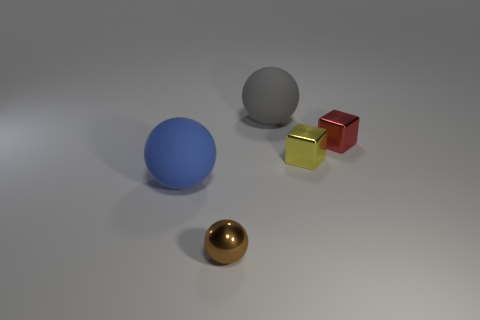What number of objects are either big rubber balls on the right side of the big blue sphere or metallic blocks?
Offer a very short reply. 3. Is the number of blue rubber objects in front of the tiny brown metal object greater than the number of matte spheres in front of the large blue thing?
Your answer should be compact. No. How many matte things are tiny balls or big balls?
Offer a terse response. 2. Is the number of tiny brown metallic objects left of the large gray object less than the number of big balls that are to the left of the brown sphere?
Offer a very short reply. No. How many objects are either tiny red shiny blocks or small objects that are to the left of the small red cube?
Offer a very short reply. 3. There is another object that is the same size as the blue object; what is it made of?
Offer a very short reply. Rubber. Is the red object made of the same material as the big gray thing?
Your answer should be very brief. No. What is the color of the tiny thing that is in front of the red shiny object and behind the tiny brown metallic ball?
Keep it short and to the point. Yellow. Is the color of the tiny shiny block on the right side of the tiny yellow cube the same as the shiny sphere?
Provide a short and direct response. No. The red metallic object that is the same size as the brown thing is what shape?
Provide a short and direct response. Cube. 